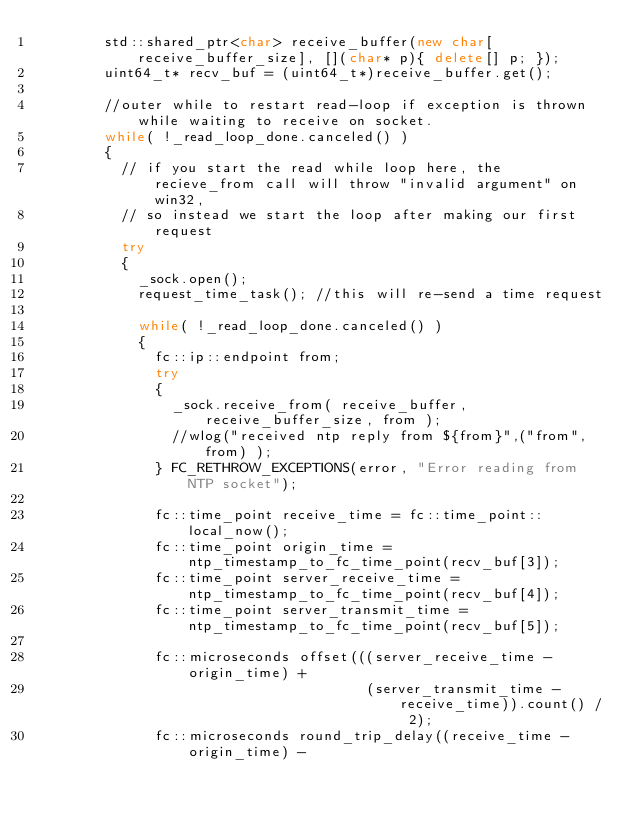Convert code to text. <code><loc_0><loc_0><loc_500><loc_500><_C++_>        std::shared_ptr<char> receive_buffer(new char[receive_buffer_size], [](char* p){ delete[] p; });
        uint64_t* recv_buf = (uint64_t*)receive_buffer.get();

        //outer while to restart read-loop if exception is thrown while waiting to receive on socket.
        while( !_read_loop_done.canceled() )
        {
          // if you start the read while loop here, the recieve_from call will throw "invalid argument" on win32,
          // so instead we start the loop after making our first request
          try 
          {
            _sock.open();
            request_time_task(); //this will re-send a time request

            while( !_read_loop_done.canceled() )
            {
              fc::ip::endpoint from;
              try
              {
                _sock.receive_from( receive_buffer, receive_buffer_size, from );
                //wlog("received ntp reply from ${from}",("from",from) );
              } FC_RETHROW_EXCEPTIONS(error, "Error reading from NTP socket");

              fc::time_point receive_time = fc::time_point::local_now();
              fc::time_point origin_time = ntp_timestamp_to_fc_time_point(recv_buf[3]);
              fc::time_point server_receive_time = ntp_timestamp_to_fc_time_point(recv_buf[4]);
              fc::time_point server_transmit_time = ntp_timestamp_to_fc_time_point(recv_buf[5]);

              fc::microseconds offset(((server_receive_time - origin_time) +
                                       (server_transmit_time - receive_time)).count() / 2);
              fc::microseconds round_trip_delay((receive_time - origin_time) -</code> 